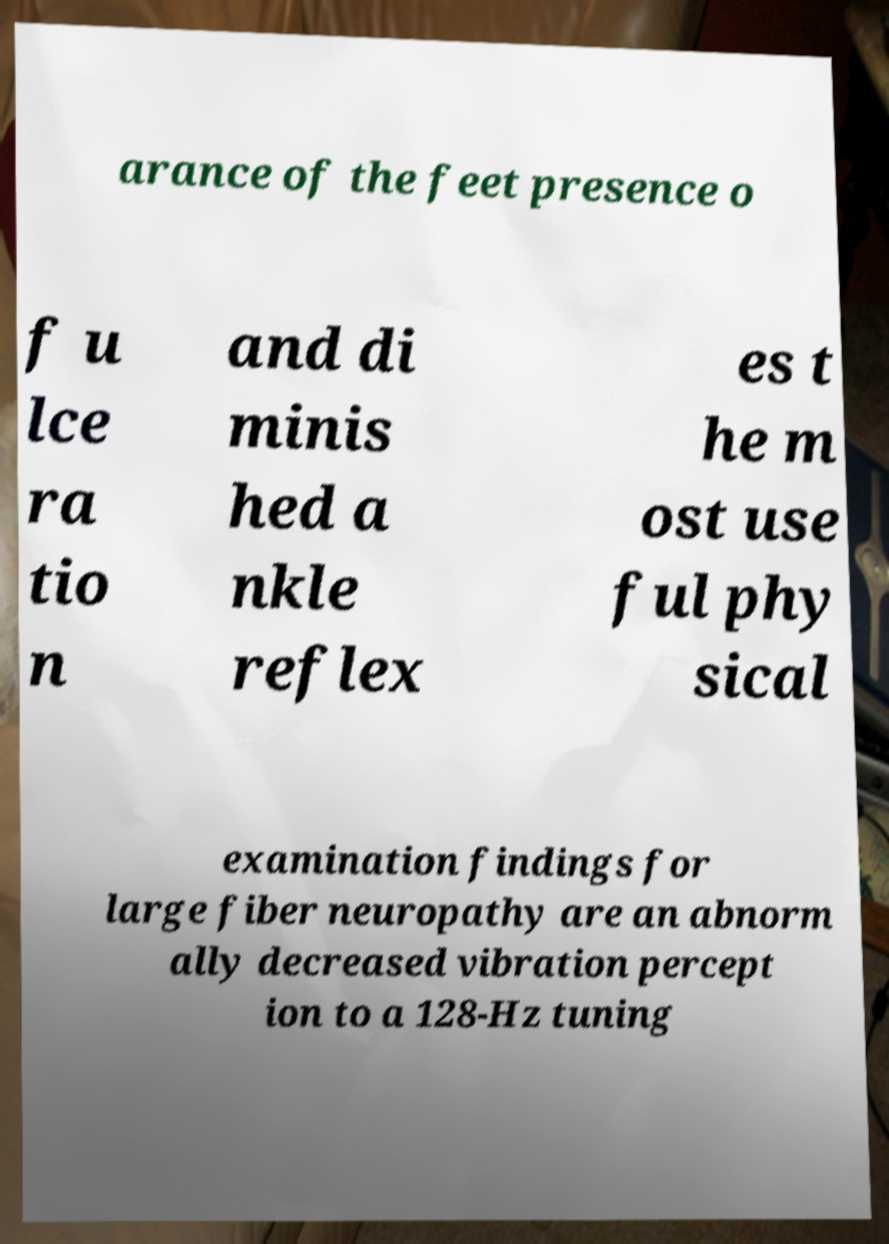Please identify and transcribe the text found in this image. arance of the feet presence o f u lce ra tio n and di minis hed a nkle reflex es t he m ost use ful phy sical examination findings for large fiber neuropathy are an abnorm ally decreased vibration percept ion to a 128-Hz tuning 